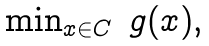<formula> <loc_0><loc_0><loc_500><loc_500>\begin{array} { l r l } & \min _ { x \in C } & g ( x ) , \end{array}</formula> 